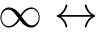<formula> <loc_0><loc_0><loc_500><loc_500>\infty \leftrightarrow</formula> 